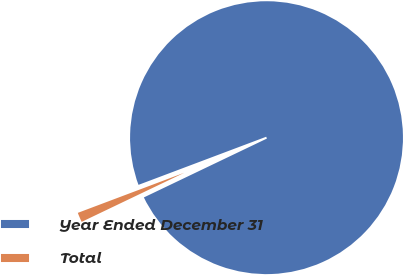<chart> <loc_0><loc_0><loc_500><loc_500><pie_chart><fcel>Year Ended December 31<fcel>Total<nl><fcel>98.63%<fcel>1.37%<nl></chart> 